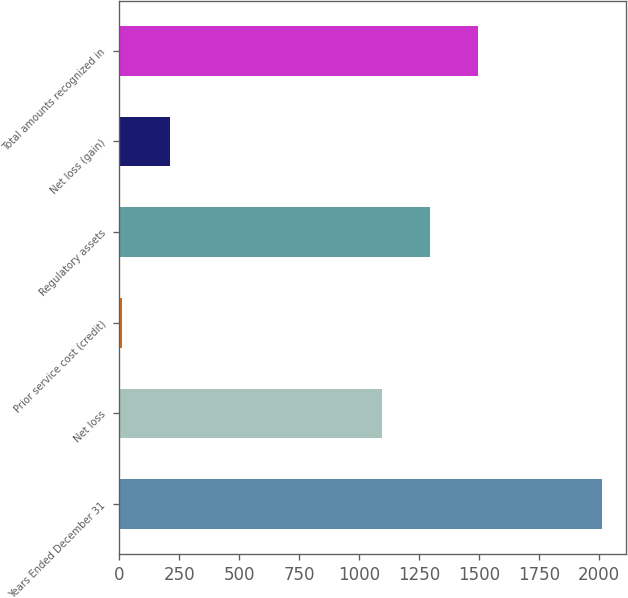<chart> <loc_0><loc_0><loc_500><loc_500><bar_chart><fcel>Years Ended December 31<fcel>Net loss<fcel>Prior service cost (credit)<fcel>Regulatory assets<fcel>Net loss (gain)<fcel>Total amounts recognized in<nl><fcel>2012<fcel>1095<fcel>13<fcel>1294.9<fcel>212.9<fcel>1494.8<nl></chart> 